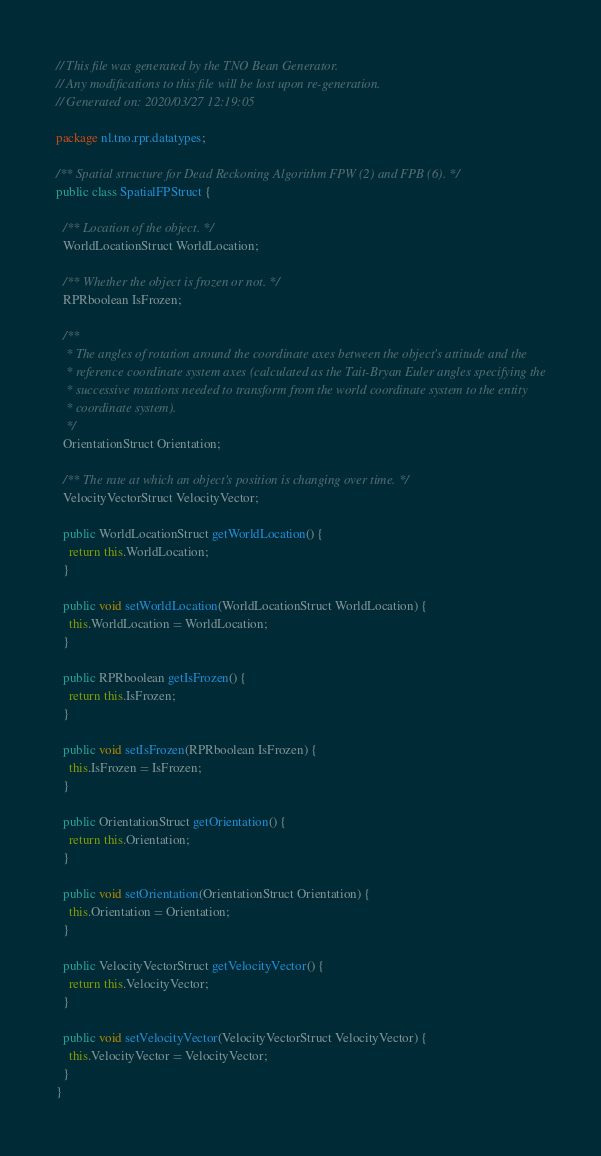Convert code to text. <code><loc_0><loc_0><loc_500><loc_500><_Java_>// This file was generated by the TNO Bean Generator.
// Any modifications to this file will be lost upon re-generation.
// Generated on: 2020/03/27 12:19:05

package nl.tno.rpr.datatypes;

/** Spatial structure for Dead Reckoning Algorithm FPW (2) and FPB (6). */
public class SpatialFPStruct {

  /** Location of the object. */
  WorldLocationStruct WorldLocation;

  /** Whether the object is frozen or not. */
  RPRboolean IsFrozen;

  /**
   * The angles of rotation around the coordinate axes between the object's attitude and the
   * reference coordinate system axes (calculated as the Tait-Bryan Euler angles specifying the
   * successive rotations needed to transform from the world coordinate system to the entity
   * coordinate system).
   */
  OrientationStruct Orientation;

  /** The rate at which an object's position is changing over time. */
  VelocityVectorStruct VelocityVector;

  public WorldLocationStruct getWorldLocation() {
    return this.WorldLocation;
  }

  public void setWorldLocation(WorldLocationStruct WorldLocation) {
    this.WorldLocation = WorldLocation;
  }

  public RPRboolean getIsFrozen() {
    return this.IsFrozen;
  }

  public void setIsFrozen(RPRboolean IsFrozen) {
    this.IsFrozen = IsFrozen;
  }

  public OrientationStruct getOrientation() {
    return this.Orientation;
  }

  public void setOrientation(OrientationStruct Orientation) {
    this.Orientation = Orientation;
  }

  public VelocityVectorStruct getVelocityVector() {
    return this.VelocityVector;
  }

  public void setVelocityVector(VelocityVectorStruct VelocityVector) {
    this.VelocityVector = VelocityVector;
  }
}
</code> 